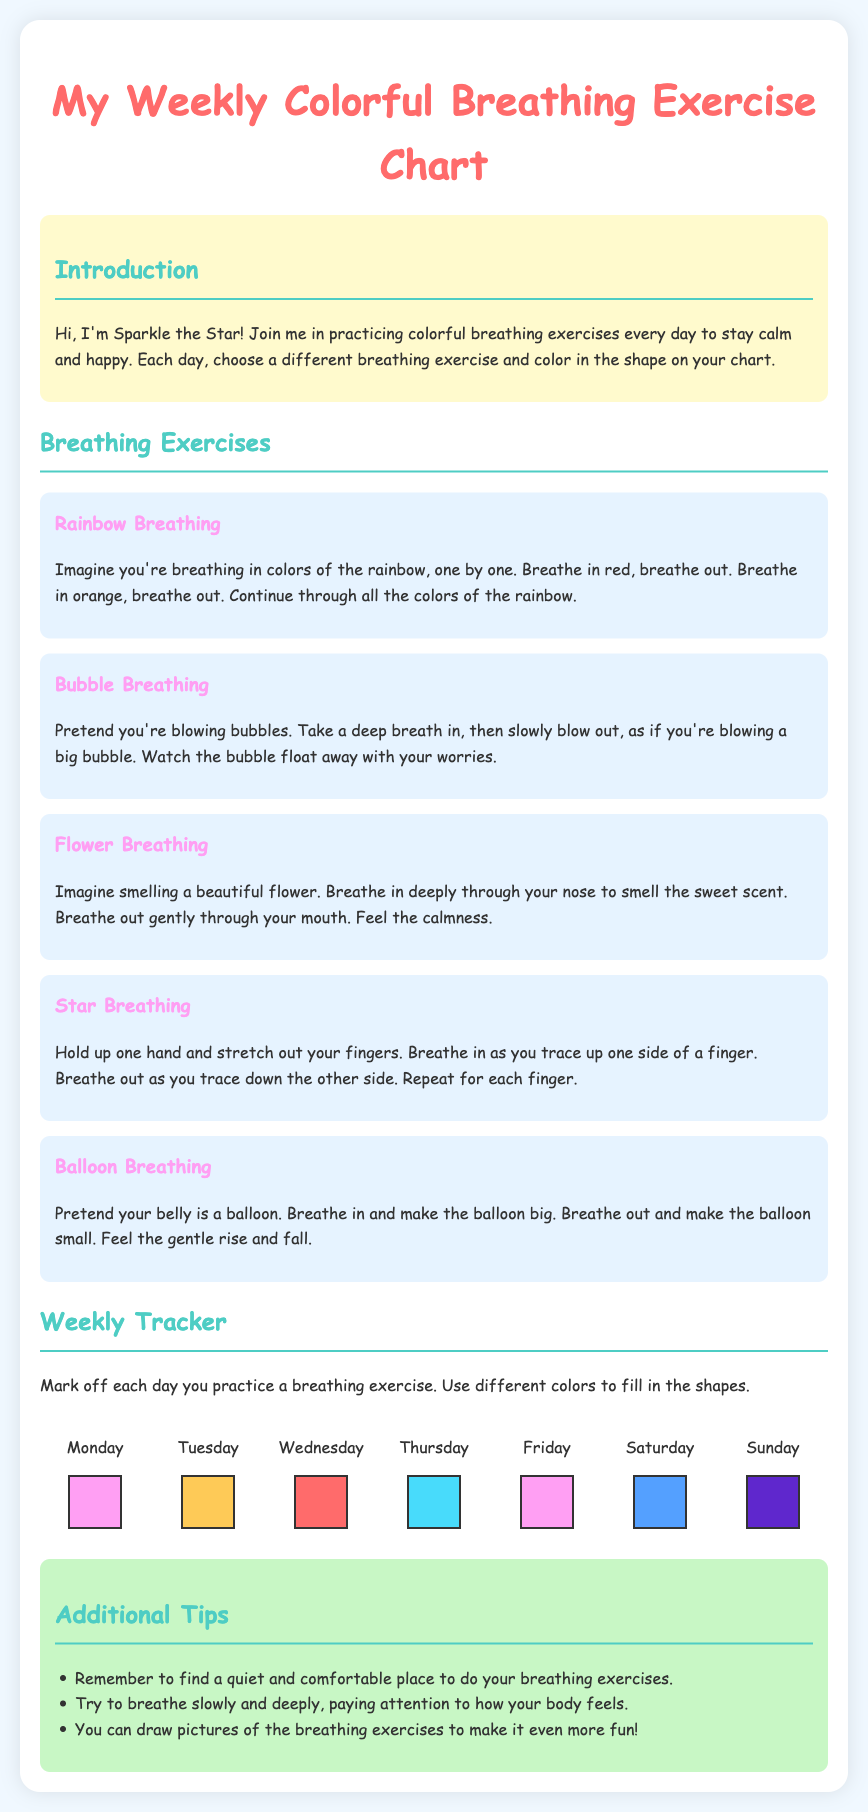What is the title of the document? The title of the document is displayed prominently at the top of the page in the heading section.
Answer: My Weekly Colorful Breathing Exercise Chart Who is the character introducing the breathing exercises? The character introducing the exercises is mentioned in the introduction section of the document.
Answer: Sparkle the Star How many breathing exercises are listed? The total number of breathing exercises is found by counting the listed exercises in the document.
Answer: Five What shape is associated with Friday? The shape for Friday is mentioned in the weekly tracker section of the document.
Answer: Triangle In which section can you find additional tips? The section that contains extra advice is indicated by a specific heading in the document.
Answer: Additional Tips Which day of the week features the circle shape? The day related to the circle shape is specified in the weekly tracker section.
Answer: Wednesday What color is the background of the breathing exercise section? The background color for that section can be identified from the document's styling descriptions.
Answer: Light blue What action do you take for each breathing exercise practiced? The action you take to indicate practice is explained in the paragraph about the weekly tracker.
Answer: Mark off each day 